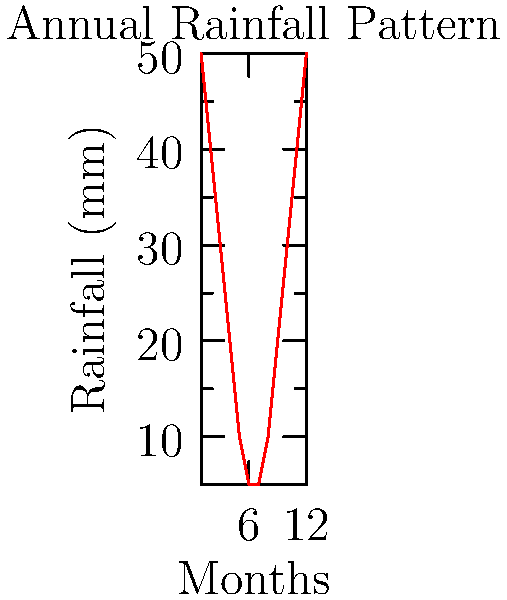Based on the annual rainfall pattern shown in the graph, calculate the total volume of rainwater that can be harvested in a year from a roof with an area of 100 m². Assume a runoff coefficient of 0.8 for the roof material. Express your answer in cubic meters (m³). To calculate the total volume of rainwater that can be harvested:

1. Calculate total annual rainfall:
   Sum of monthly rainfall = 50 + 40 + 30 + 20 + 10 + 5 + 5 + 10 + 20 + 30 + 40 + 50 = 310 mm

2. Convert rainfall from mm to m:
   310 mm = 0.31 m

3. Calculate the catchment area:
   Given roof area = 100 m²

4. Apply the runoff coefficient:
   Effective catchment area = 100 m² × 0.8 = 80 m²

5. Calculate the volume of water:
   Volume = Rainfall (m) × Effective catchment area (m²)
   Volume = 0.31 m × 80 m² = 24.8 m³

Therefore, the total volume of rainwater that can be harvested in a year is 24.8 m³.
Answer: 24.8 m³ 